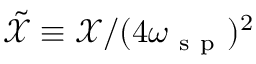Convert formula to latex. <formula><loc_0><loc_0><loc_500><loc_500>\tilde { \mathcal { X } } \equiv \mathcal { X } / ( 4 \omega _ { s p } ) ^ { 2 }</formula> 